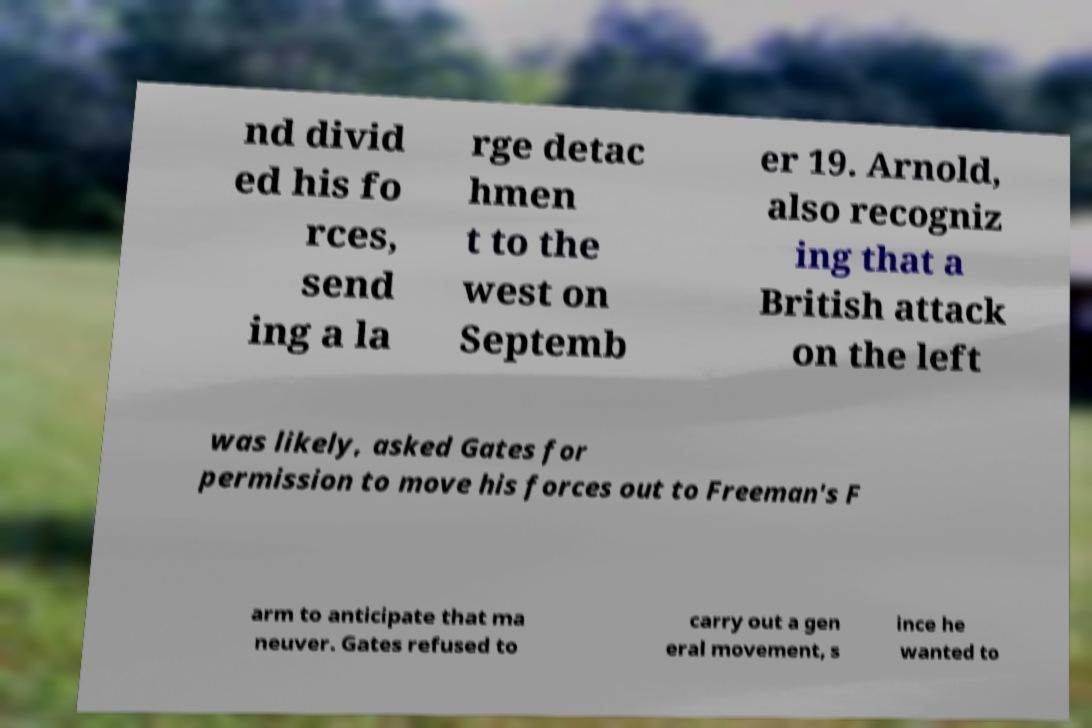What messages or text are displayed in this image? I need them in a readable, typed format. nd divid ed his fo rces, send ing a la rge detac hmen t to the west on Septemb er 19. Arnold, also recogniz ing that a British attack on the left was likely, asked Gates for permission to move his forces out to Freeman's F arm to anticipate that ma neuver. Gates refused to carry out a gen eral movement, s ince he wanted to 